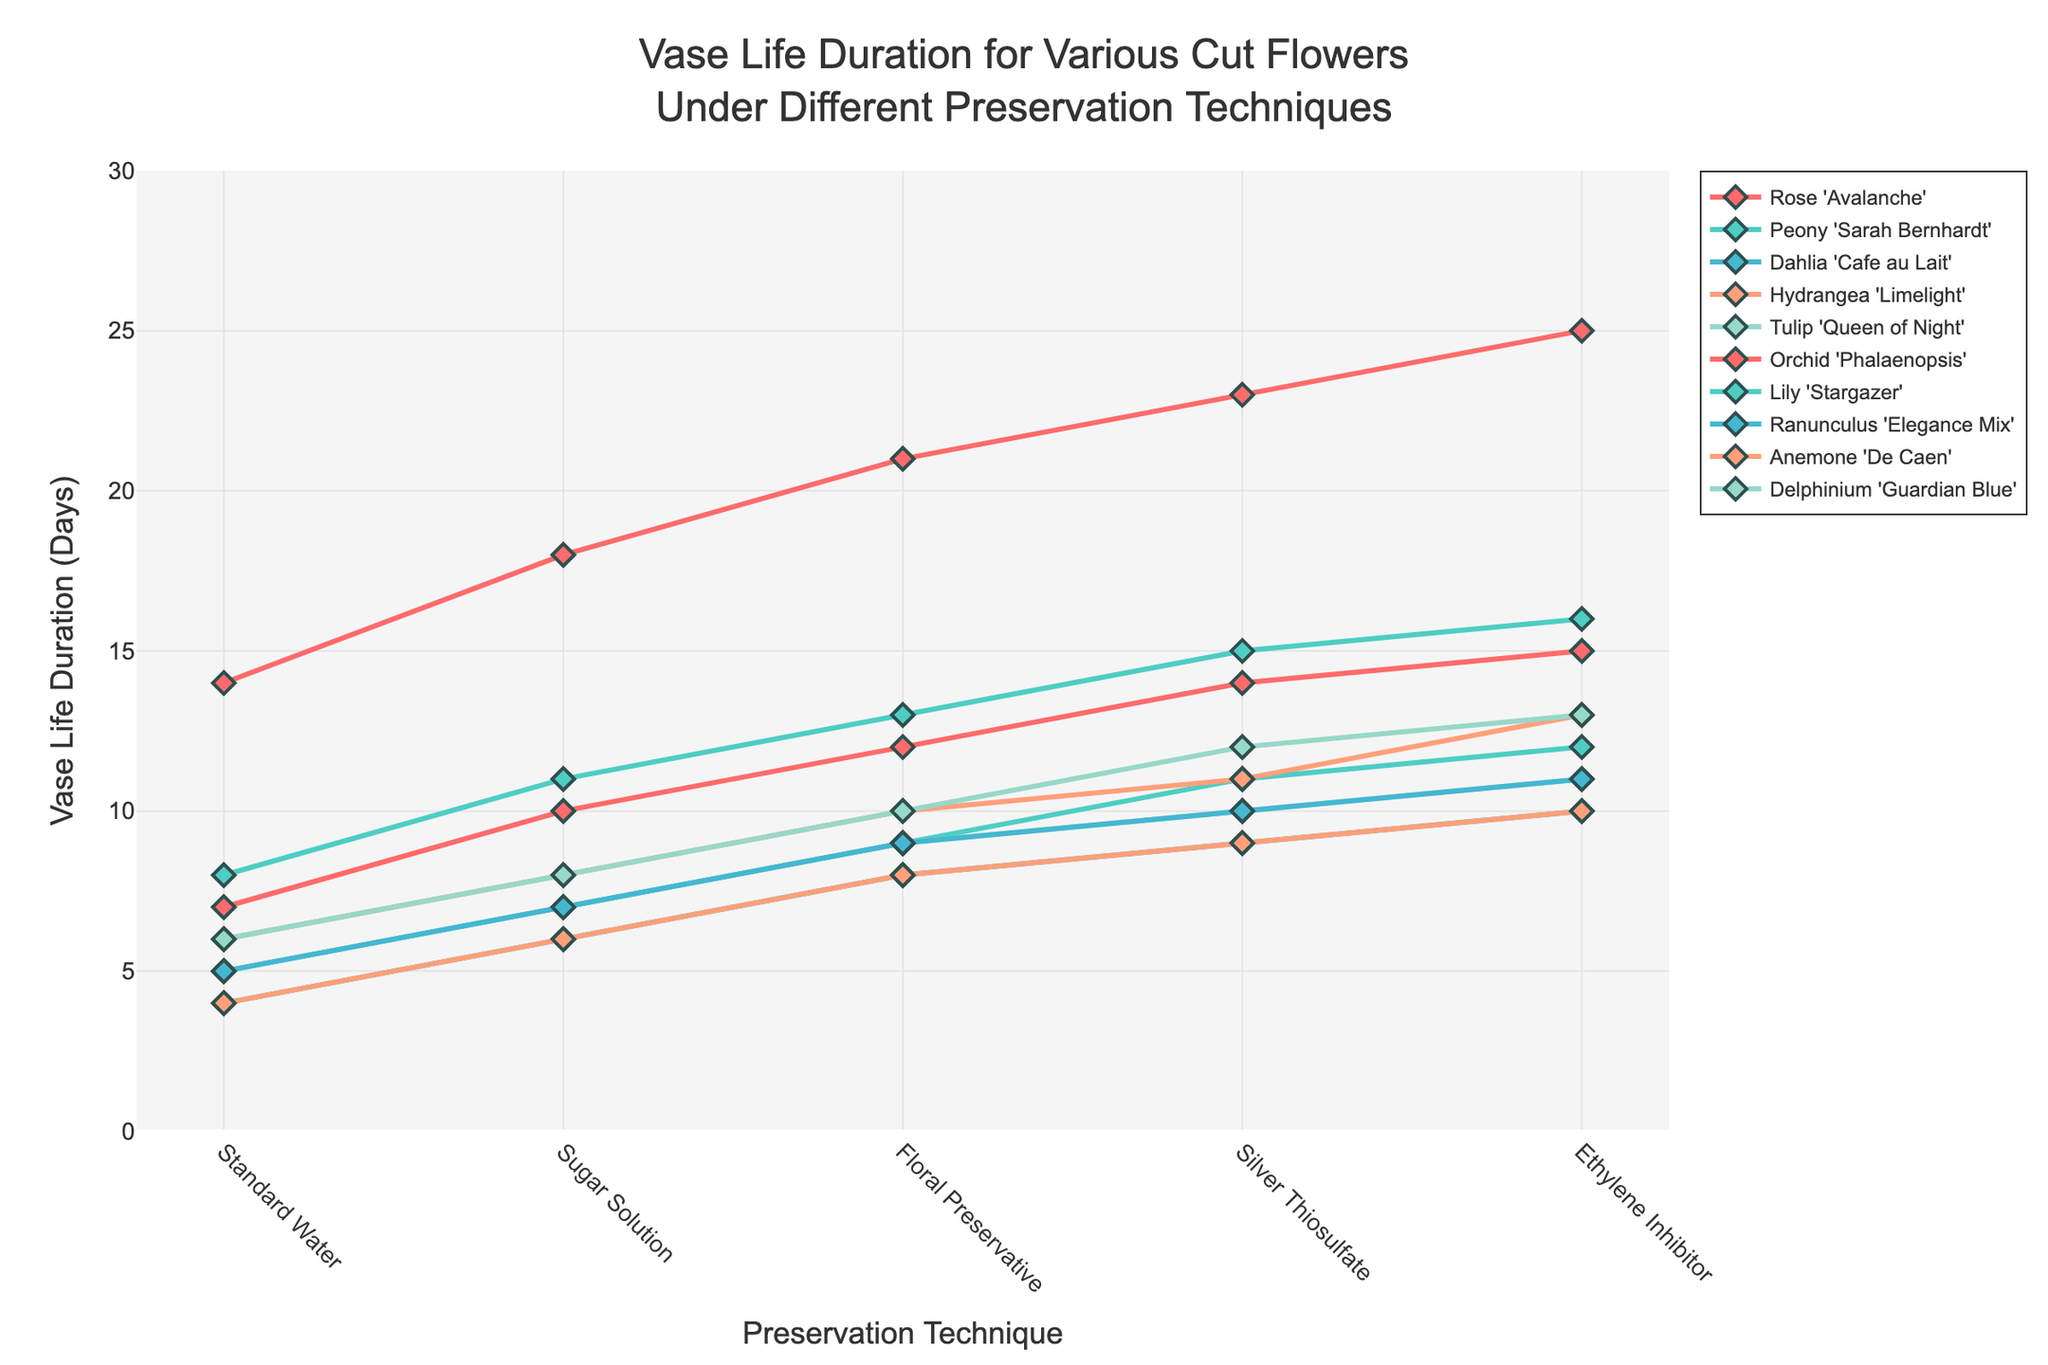What is the flower species with the longest vase life under the "Silver Thiosulfate" preservation technique? First, locate the "Silver Thiosulfate" column. Then, find the maximum value in that column. Finally, identify the corresponding flower species. The longest vase life under "Silver Thiosulfate" is 23 days for Orchid 'Phalaenopsis'.
Answer: Orchid 'Phalaenopsis' Which flower species improved the most in vase life when using "Floral Preservative" instead of "Standard Water"? To find this, calculate the difference between "Floral Preservative" and "Standard Water" for each species, then find the maximum difference. Orchid 'Phalaenopsis' has the highest difference of 7 days (21-14).
Answer: Orchid 'Phalaenopsis' What is the average vase life of Hydrangea 'Limelight' across all preservation techniques? Sum the vase life values for Hydrangea 'Limelight': 6 + 8 + 10 + 11 + 13 = 48. Then divide by the number of techniques (5). The average vase life is 48/5 = 9.6 days.
Answer: 9.6 days Which two flower species have the closest vase life durations under the "Ethylene Inhibitor" preservation technique? Compare the vase life durations of all species under "Ethylene Inhibitor" and find the two with the smallest absolute difference. Dahlia 'Cafe au Lait' and Anemone 'De Caen' both have a vase life of 10 days.
Answer: Dahlia 'Cafe au Lait' and Anemone 'De Caen' By how many days does the vase life of Tulip 'Queen of Night' increase when using "Ethylene Inhibitor" compared to using "Standard Water"? Subtract the vase life under "Standard Water" (5 days) from that under "Ethylene Inhibitor" (11 days). The increase is 11 - 5 = 6 days.
Answer: 6 days What is the median vase life for Delphinium 'Guardian Blue' across all preservation techniques? Arrange the vase life values in ascending order: 6, 8, 10, 12, 13. The median value, being the middle one in an odd-number series, is 10 days.
Answer: 10 days Which preservation technique provides the second longest vase life on average across all flower species? Calculate the average vase life for each preservation technique. The results are:
Standard Water: 6.4,
Sugar Solution: 8.6,
Floral Preservative: 10.9,
Silver Thiosulfate: 12.3,
Ethylene Inhibitor: 13.6.
The second longest average is for "Silver Thiosulfate" with 12.3 days.
Answer: Silver Thiosulfate For Rose 'Avalanche', how much does the vase life differ between the best and worst preservation techniques? Find the vase life for the best technique (Ethylene Inhibitor: 15 days) and the worst (Standard Water: 7 days). The difference is 15 - 7 = 8 days.
Answer: 8 days 